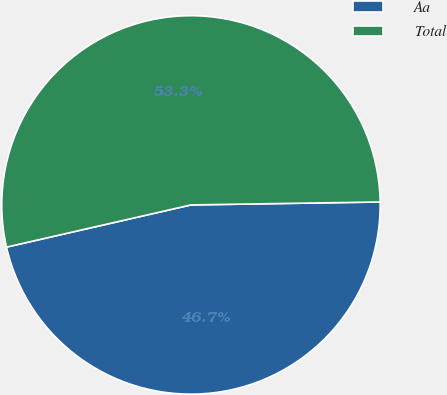Convert chart to OTSL. <chart><loc_0><loc_0><loc_500><loc_500><pie_chart><fcel>Aa<fcel>Total<nl><fcel>46.67%<fcel>53.33%<nl></chart> 